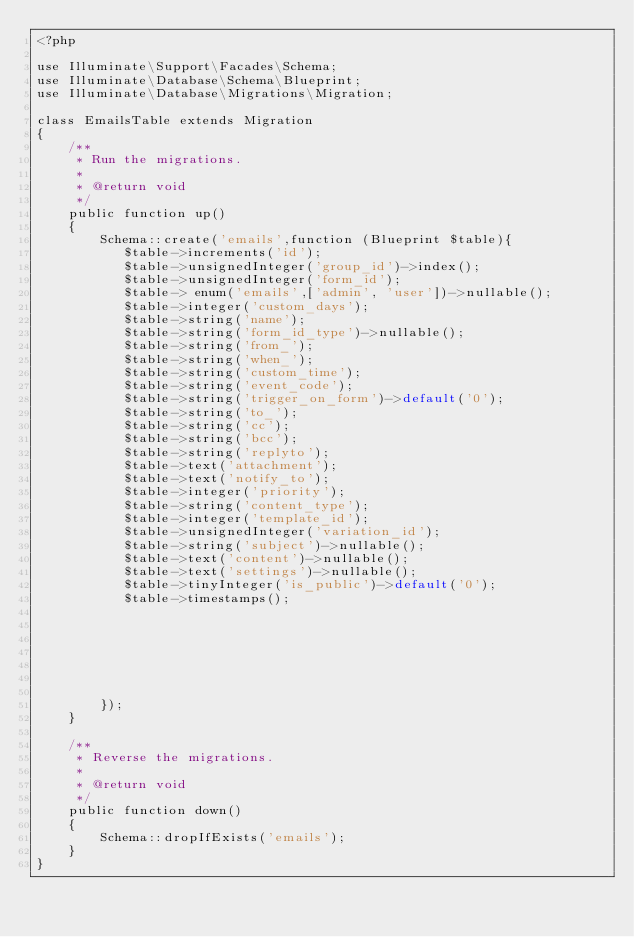<code> <loc_0><loc_0><loc_500><loc_500><_PHP_><?php

use Illuminate\Support\Facades\Schema;
use Illuminate\Database\Schema\Blueprint;
use Illuminate\Database\Migrations\Migration;

class EmailsTable extends Migration
{
    /**
     * Run the migrations.
     *
     * @return void
     */
    public function up()
    {
        Schema::create('emails',function (Blueprint $table){
           $table->increments('id');
           $table->unsignedInteger('group_id')->index();
           $table->unsignedInteger('form_id');
           $table-> enum('emails',['admin', 'user'])->nullable();
           $table->integer('custom_days');
           $table->string('name');
           $table->string('form_id_type')->nullable();
           $table->string('from_');
           $table->string('when_');
           $table->string('custom_time');
           $table->string('event_code');
           $table->string('trigger_on_form')->default('0');
           $table->string('to_');
           $table->string('cc');
           $table->string('bcc');
           $table->string('replyto');
           $table->text('attachment');
           $table->text('notify_to');
           $table->integer('priority');
           $table->string('content_type');
           $table->integer('template_id');
           $table->unsignedInteger('variation_id');
           $table->string('subject')->nullable();
           $table->text('content')->nullable();
           $table->text('settings')->nullable();
           $table->tinyInteger('is_public')->default('0');
           $table->timestamps();







        });
    }

    /**
     * Reverse the migrations.
     *
     * @return void
     */
    public function down()
    {
        Schema::dropIfExists('emails');
    }
}
</code> 